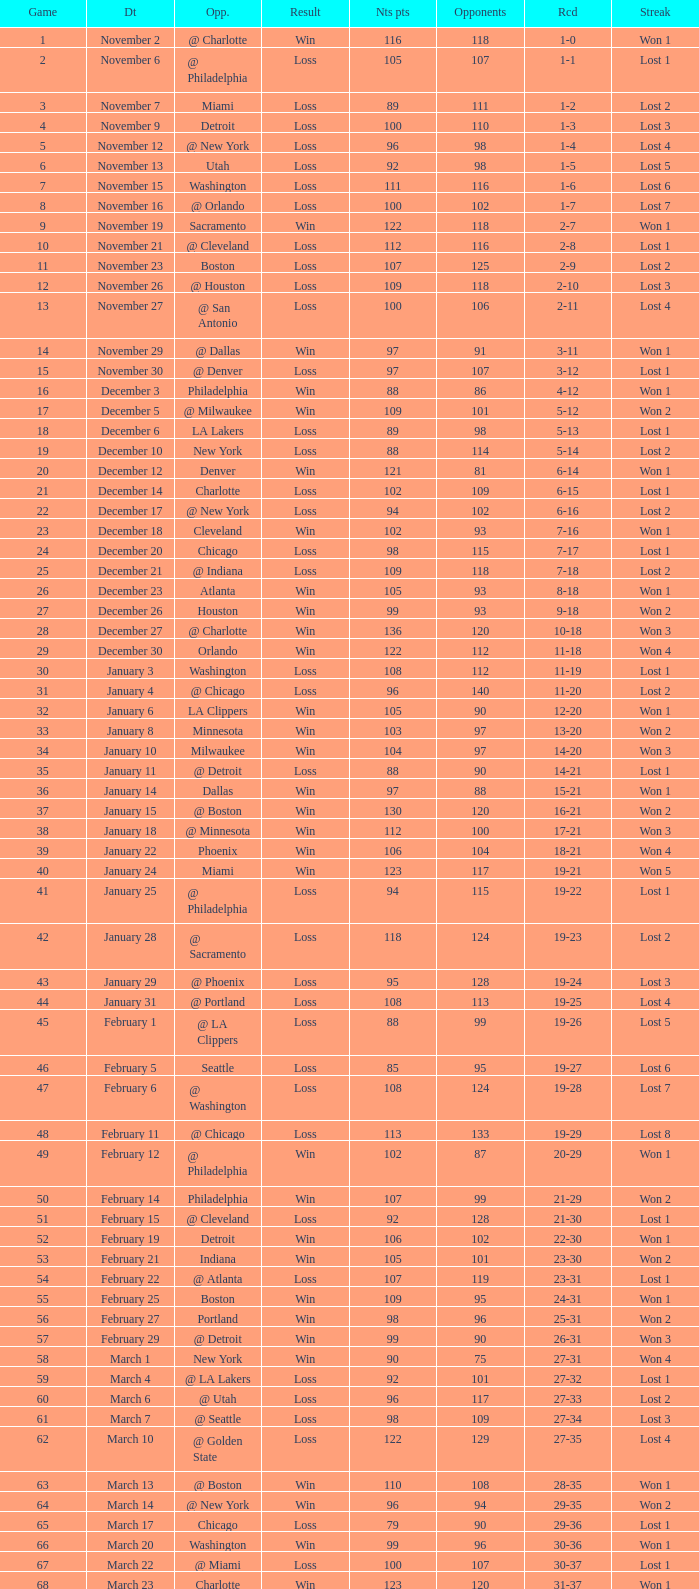How many opponents were there in a game higher than 20 on January 28? 124.0. 